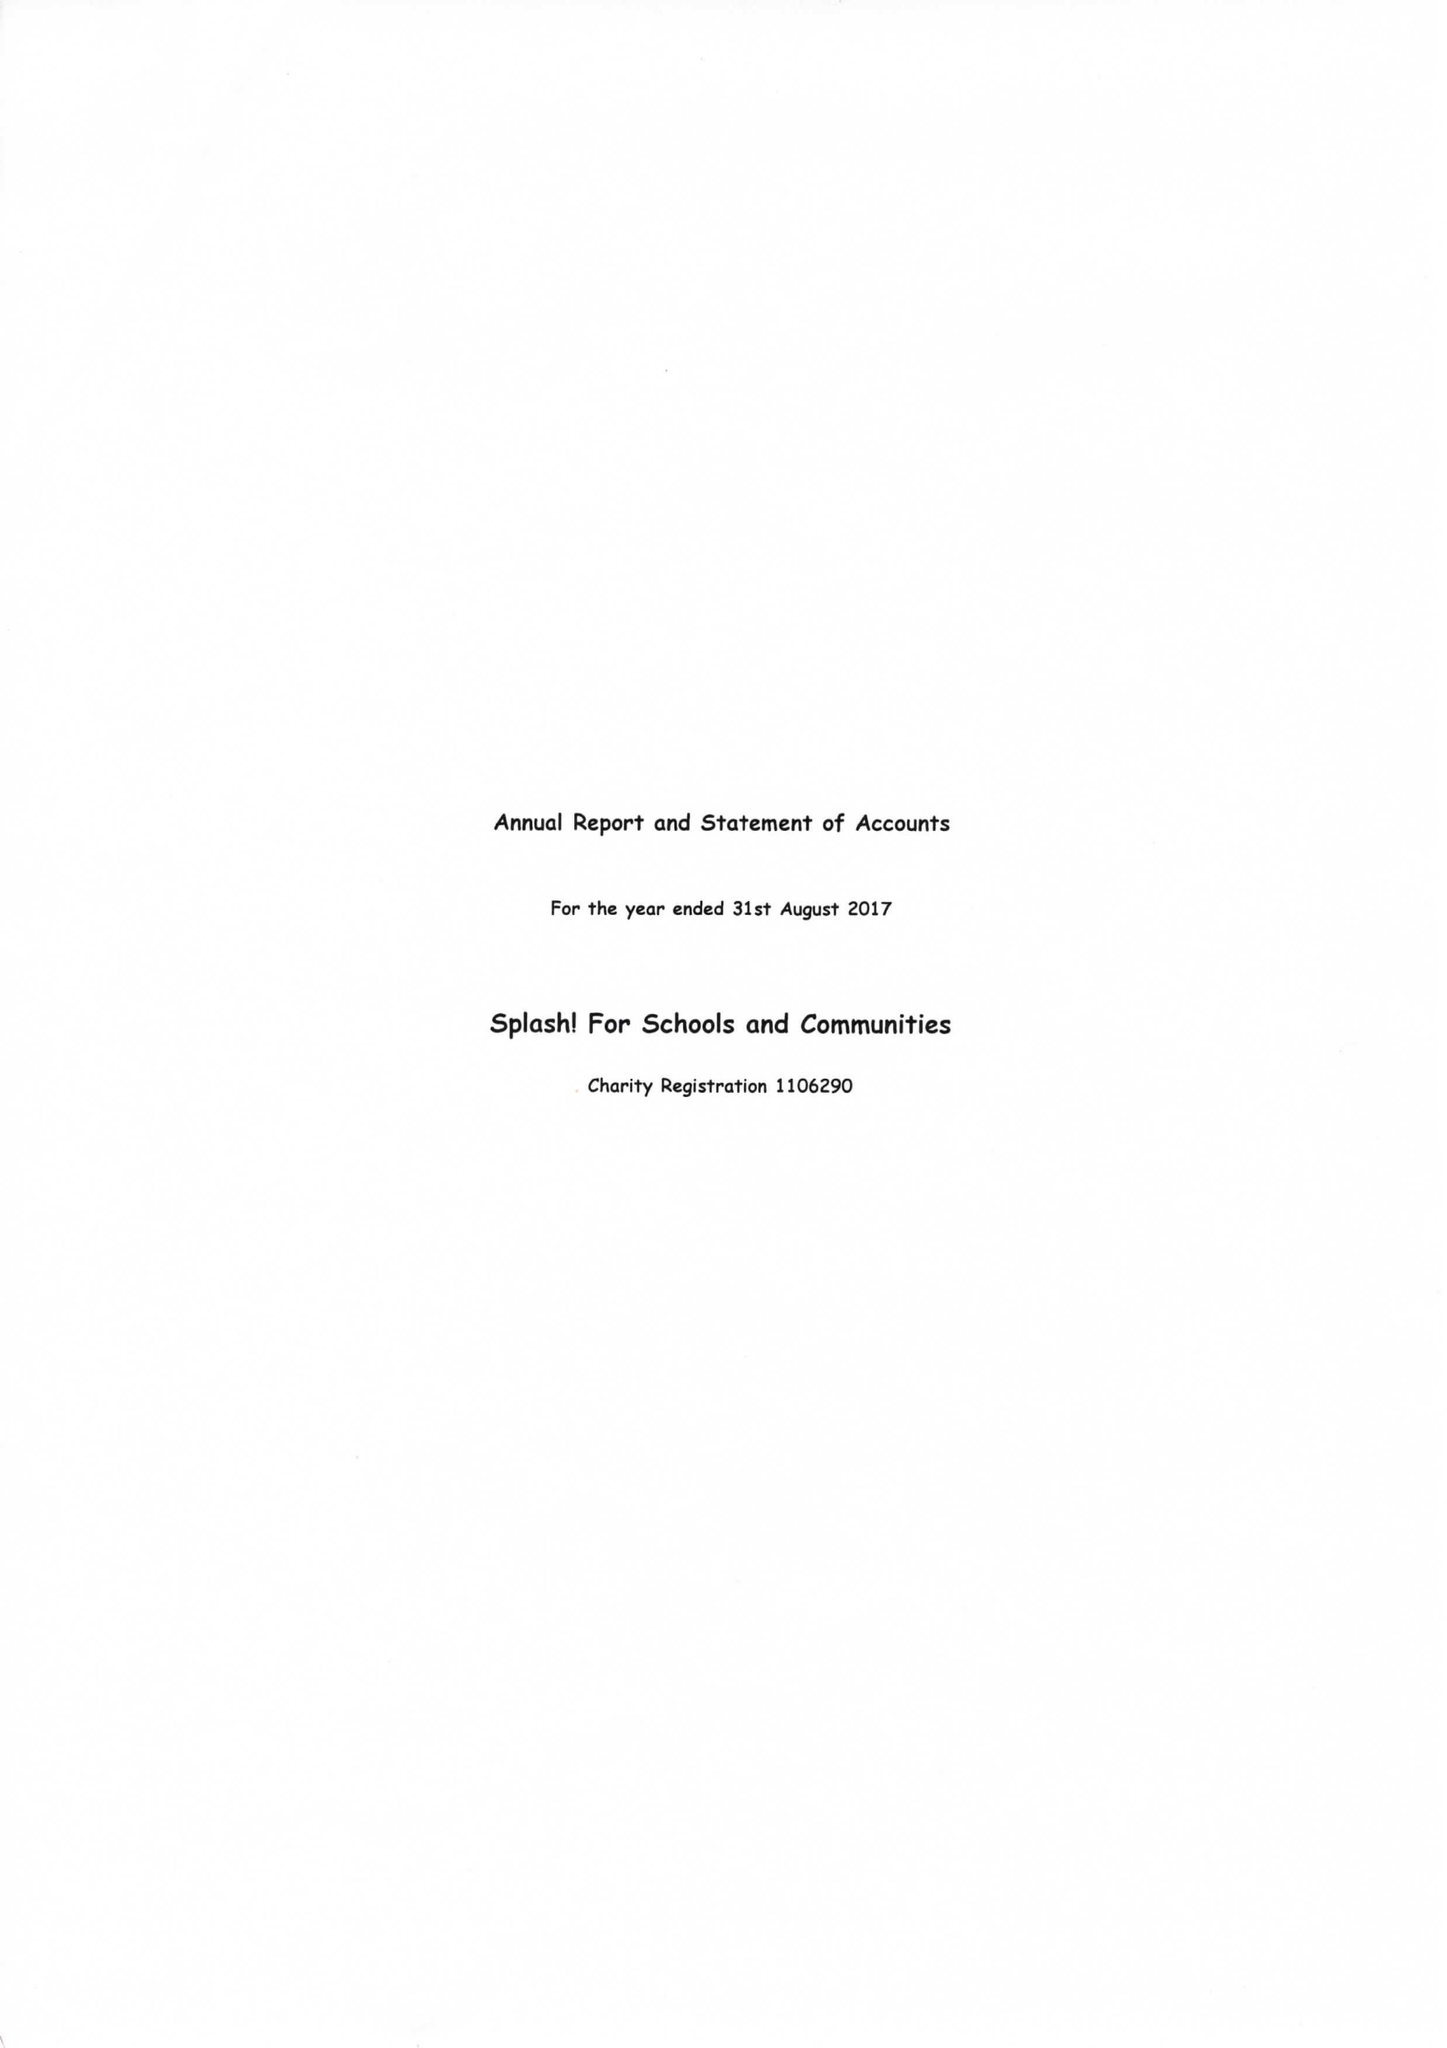What is the value for the charity_number?
Answer the question using a single word or phrase. 1106290 